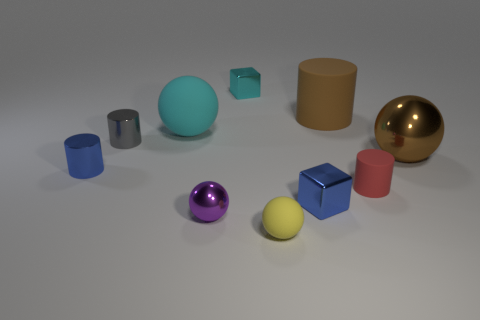There is another large object that is the same color as the large metallic thing; what shape is it?
Provide a succinct answer. Cylinder. There is a big thing that is both in front of the large rubber cylinder and behind the gray cylinder; what is its material?
Your answer should be compact. Rubber. Does the tiny rubber cylinder have the same color as the small matte ball?
Provide a short and direct response. No. There is another shiny ball that is the same size as the cyan sphere; what color is it?
Keep it short and to the point. Brown. What number of things are small rubber spheres or small matte cylinders?
Give a very brief answer. 2. There is a sphere that is both behind the small blue cube and on the left side of the small cyan metal object; what is its size?
Ensure brevity in your answer.  Large. What number of big balls are made of the same material as the yellow object?
Provide a short and direct response. 1. There is a small sphere that is the same material as the large cyan object; what color is it?
Make the answer very short. Yellow. There is a matte sphere behind the blue cube; is its color the same as the large shiny sphere?
Offer a terse response. No. There is a large brown object that is to the right of the small matte cylinder; what is it made of?
Keep it short and to the point. Metal. 